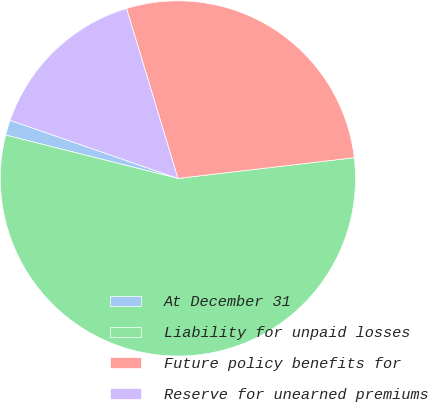<chart> <loc_0><loc_0><loc_500><loc_500><pie_chart><fcel>At December 31<fcel>Liability for unpaid losses<fcel>Future policy benefits for<fcel>Reserve for unearned premiums<nl><fcel>1.38%<fcel>55.79%<fcel>27.81%<fcel>15.02%<nl></chart> 